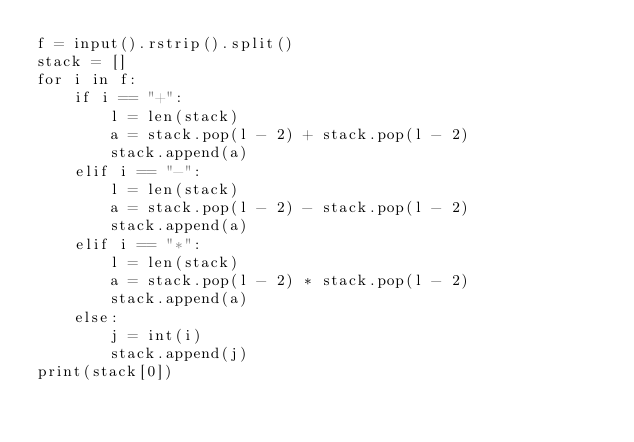Convert code to text. <code><loc_0><loc_0><loc_500><loc_500><_Python_>f = input().rstrip().split()
stack = []
for i in f:
    if i == "+":
        l = len(stack)
        a = stack.pop(l - 2) + stack.pop(l - 2)
        stack.append(a)
    elif i == "-":
        l = len(stack)
        a = stack.pop(l - 2) - stack.pop(l - 2)
        stack.append(a)
    elif i == "*":
        l = len(stack)
        a = stack.pop(l - 2) * stack.pop(l - 2)
        stack.append(a)
    else:
        j = int(i)
        stack.append(j)
print(stack[0])
</code> 